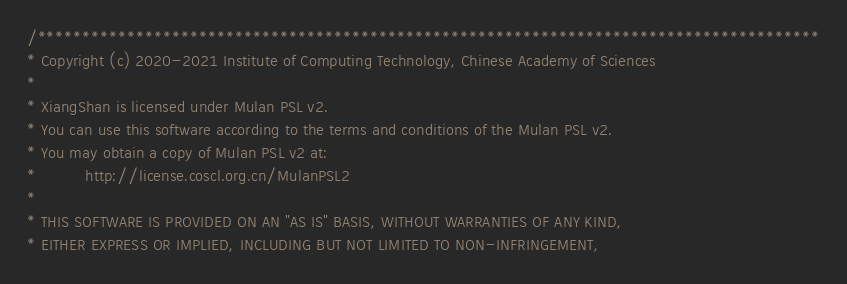Convert code to text. <code><loc_0><loc_0><loc_500><loc_500><_Scala_>/***************************************************************************************
* Copyright (c) 2020-2021 Institute of Computing Technology, Chinese Academy of Sciences
*
* XiangShan is licensed under Mulan PSL v2.
* You can use this software according to the terms and conditions of the Mulan PSL v2.
* You may obtain a copy of Mulan PSL v2 at:
*          http://license.coscl.org.cn/MulanPSL2
*
* THIS SOFTWARE IS PROVIDED ON AN "AS IS" BASIS, WITHOUT WARRANTIES OF ANY KIND,
* EITHER EXPRESS OR IMPLIED, INCLUDING BUT NOT LIMITED TO NON-INFRINGEMENT,</code> 